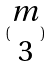Convert formula to latex. <formula><loc_0><loc_0><loc_500><loc_500>( \begin{matrix} m \\ 3 \end{matrix} )</formula> 